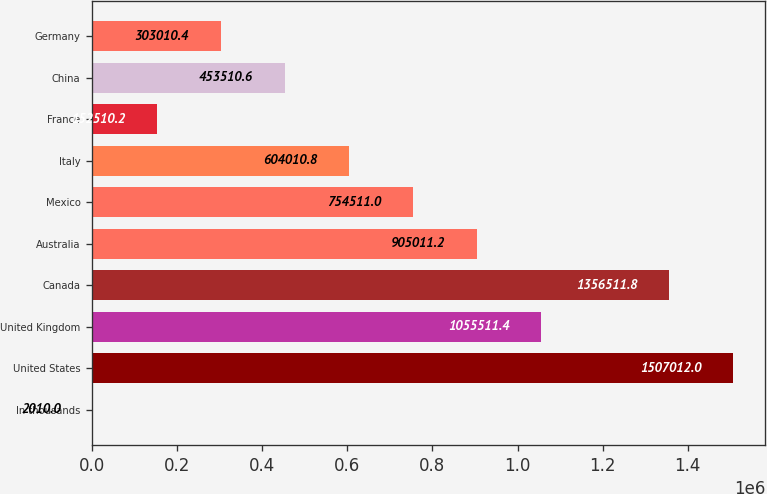<chart> <loc_0><loc_0><loc_500><loc_500><bar_chart><fcel>In thousands<fcel>United States<fcel>United Kingdom<fcel>Canada<fcel>Australia<fcel>Mexico<fcel>Italy<fcel>France<fcel>China<fcel>Germany<nl><fcel>2010<fcel>1.50701e+06<fcel>1.05551e+06<fcel>1.35651e+06<fcel>905011<fcel>754511<fcel>604011<fcel>152510<fcel>453511<fcel>303010<nl></chart> 